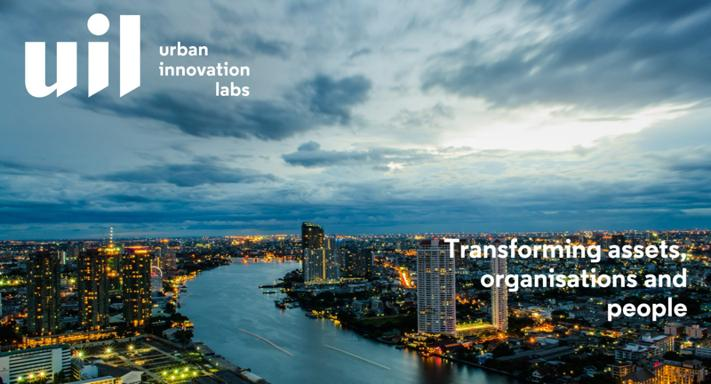What role might UIL Urban Innovation Labs play in enhancing the sustainability of this waterfront area? UIL Urban Innovation Labs could play a pivotal role in enhancing sustainability by implementing green technologies in buildings, promoting water conservation practices, and encouraging the development of public spaces that are both environmentally friendly and socially beneficial. 